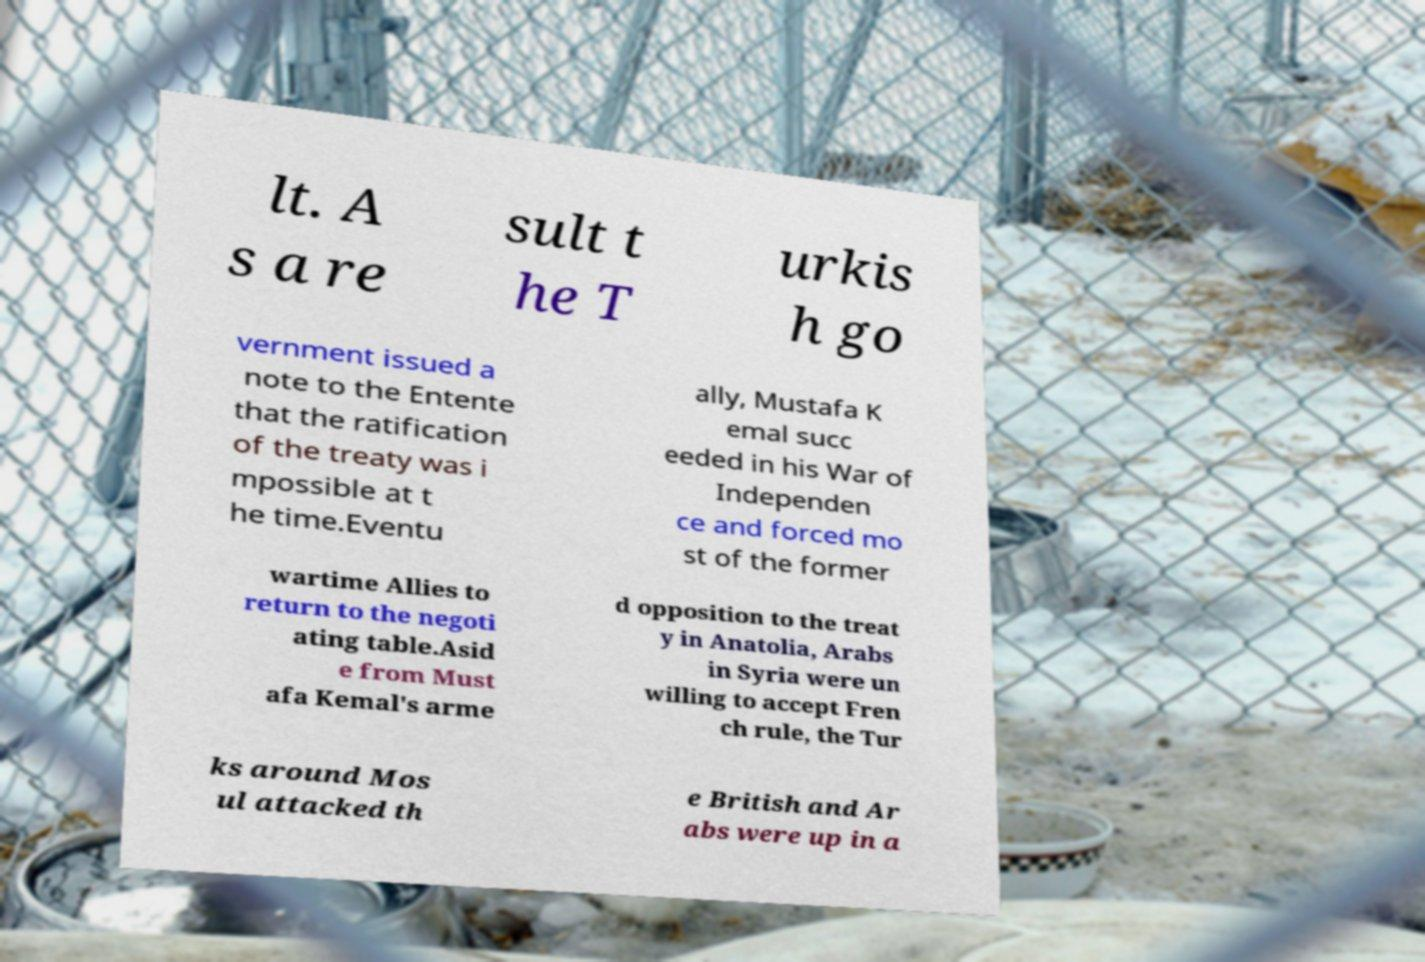Can you read and provide the text displayed in the image?This photo seems to have some interesting text. Can you extract and type it out for me? lt. A s a re sult t he T urkis h go vernment issued a note to the Entente that the ratification of the treaty was i mpossible at t he time.Eventu ally, Mustafa K emal succ eeded in his War of Independen ce and forced mo st of the former wartime Allies to return to the negoti ating table.Asid e from Must afa Kemal's arme d opposition to the treat y in Anatolia, Arabs in Syria were un willing to accept Fren ch rule, the Tur ks around Mos ul attacked th e British and Ar abs were up in a 